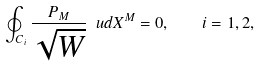<formula> <loc_0><loc_0><loc_500><loc_500>\oint _ { C _ { i } } \frac { P _ { M } } { \sqrt { W } } \ u d X ^ { M } = 0 , \quad i = 1 , 2 ,</formula> 